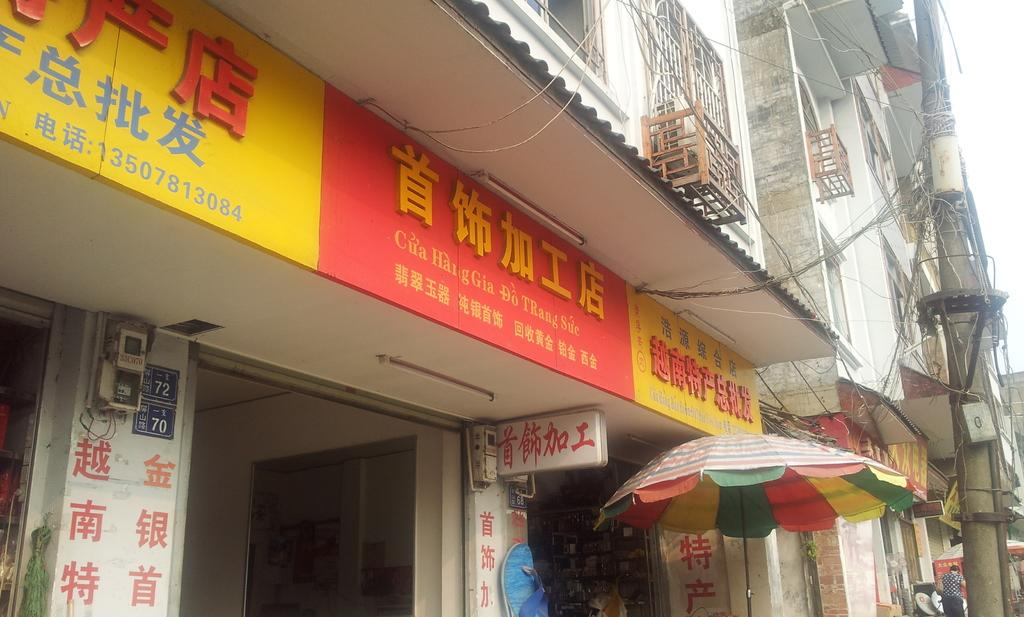What type of structures can be seen in the image? There are buildings in the image. What feature can be found on the buildings? There are windows in the image. What additional decorative elements are present in the image? There are banners in the image. What utility pole is visible in the image? There is a current pole in the image. What object is present for protection from the elements? There is an umbrella in the image. Where is the person located in the image? The person is standing on the right side of the image. What part of the natural environment is visible in the image? The sky is visible in the image. What type of yam is being used as a decoration on the banners in the image? There is no yam present in the image; the banners feature other decorative elements. What shape does the person's tongue make in the image? There is no tongue visible in the image, as it focuses on the buildings, windows, banners, current pole, umbrella, and sky. 